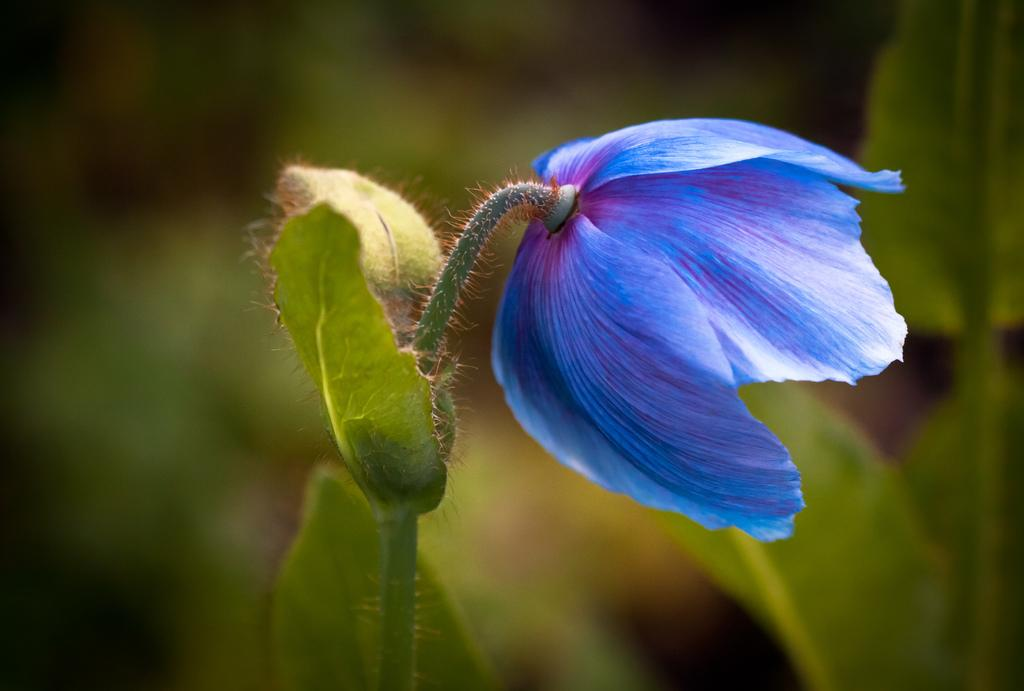What type of flower is on the plant in the image? There is a blue flower on the plant in the image. Are there any other plants visible in the image? Yes, there are other plants in the image. What color is the background of the image? The background of the image is green and blurred. How does the bridge connect the two patches of land in the image? There is no bridge present in the image; it only features plants and a green, blurred background. 